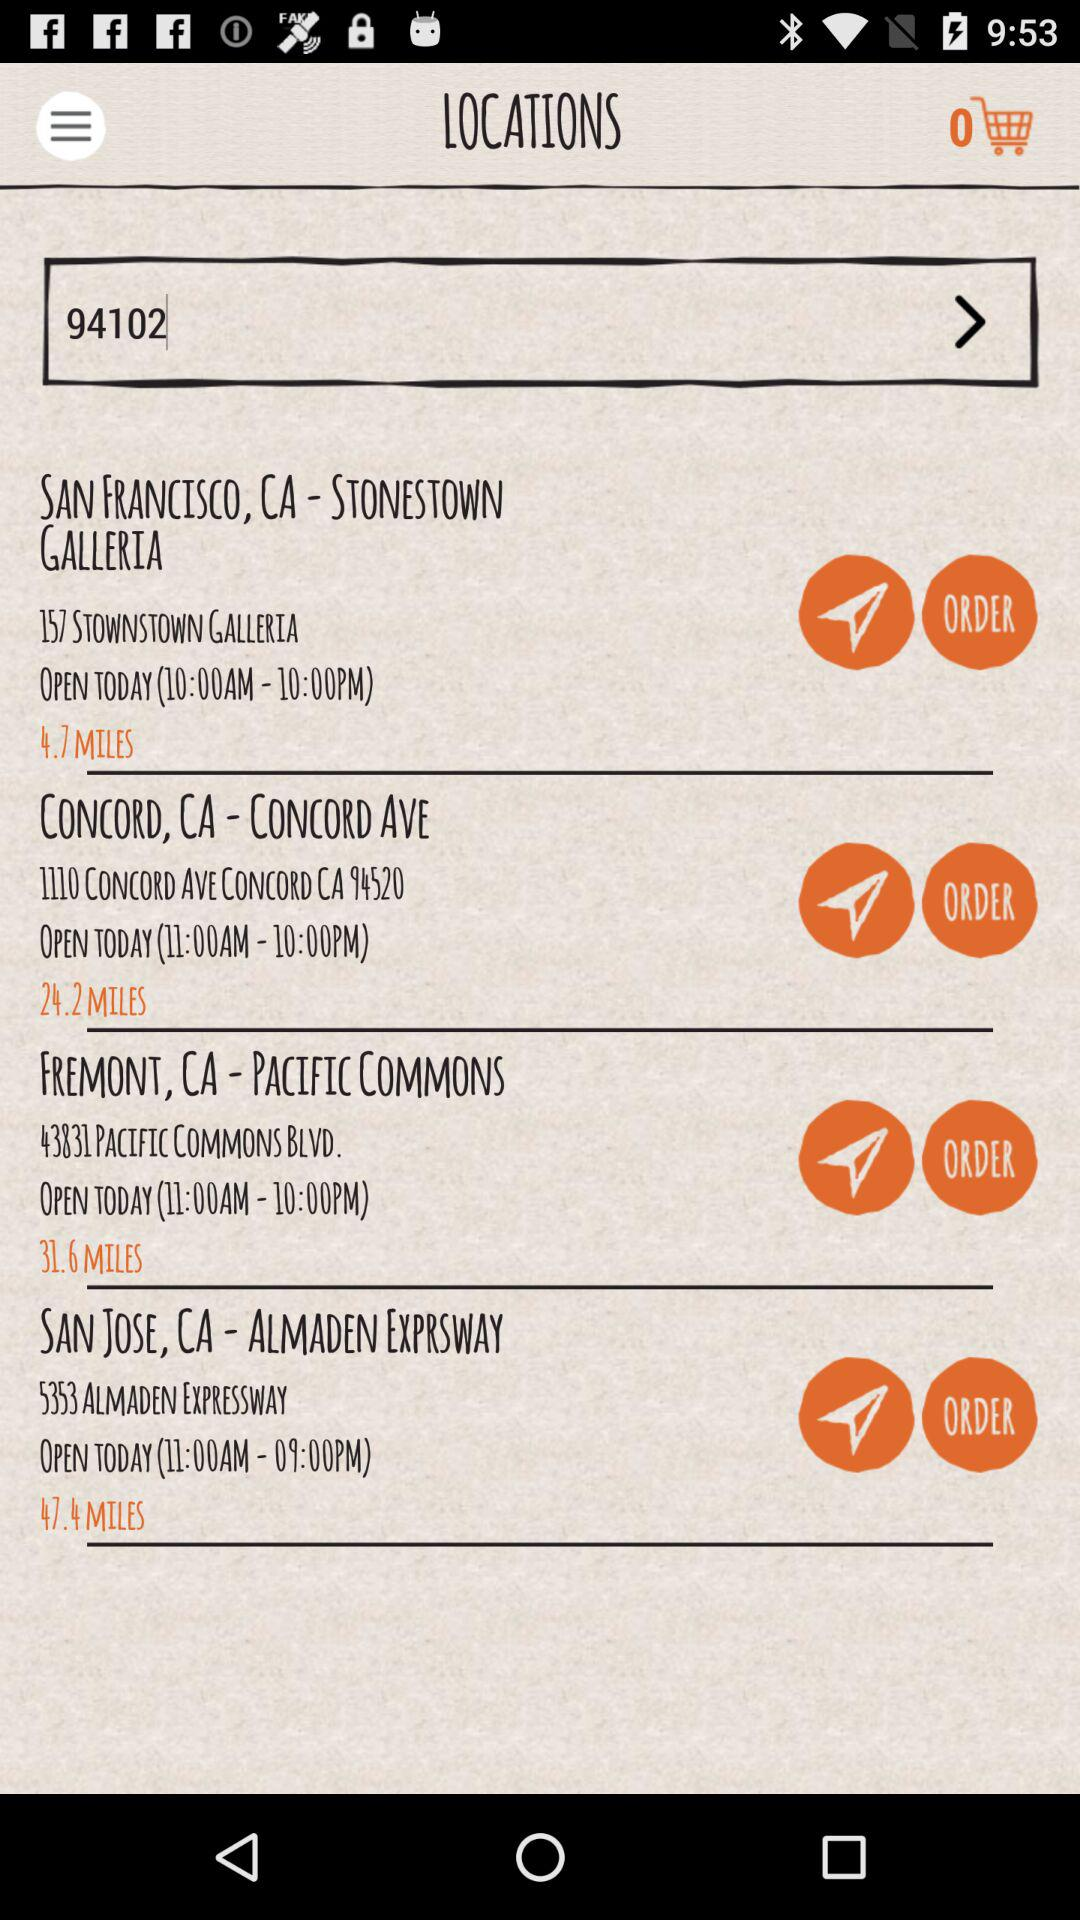What is the address of the store located in Concord Ave, Concord, CA? The address is 1110 Concord Avenue, Concord, CA 94520. 